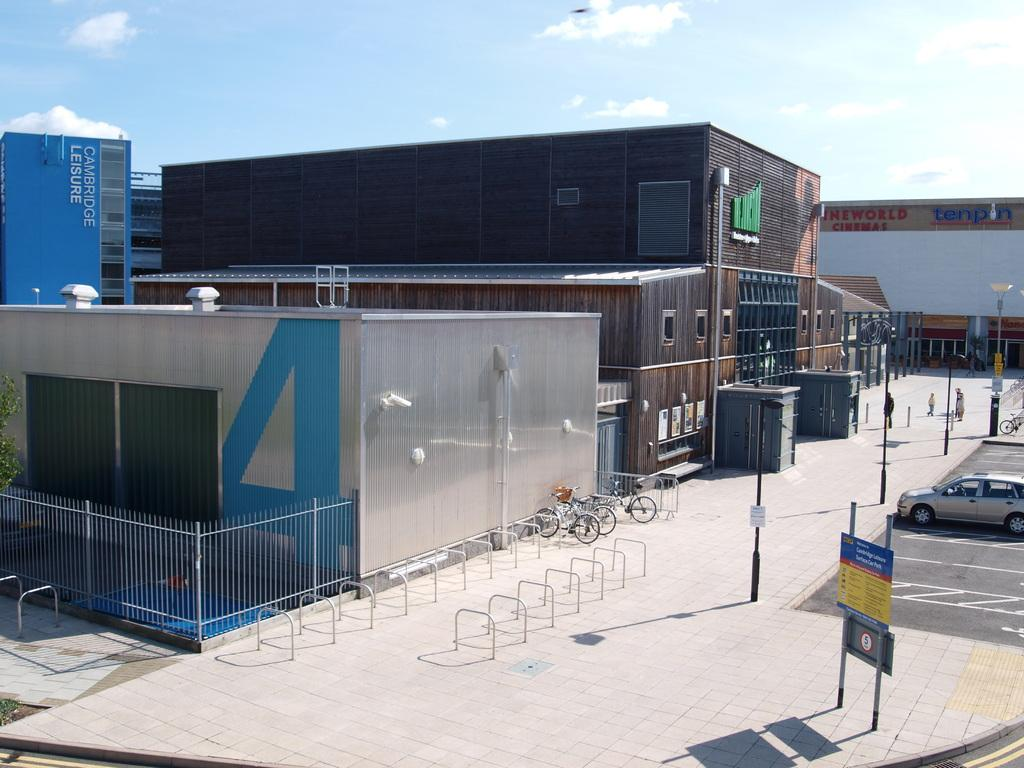What structures are located in the middle of the image? There are buildings, sheds, cycles, and poles in the middle of the image. What objects can be seen on the right side of the image? There is a car, sign boards, and a floor on the right side of the image. How many poles are visible in the image? There are poles in the middle and on the right side of the image, making a total of at least two poles visible. What is visible at the top of the image? The sky is visible at the top of the image, and there are clouds in the sky. What direction are the snakes moving in the image? There are no snakes present in the image. What type of wire is connected to the poles in the image? There is no wire connected to the poles in the image. 